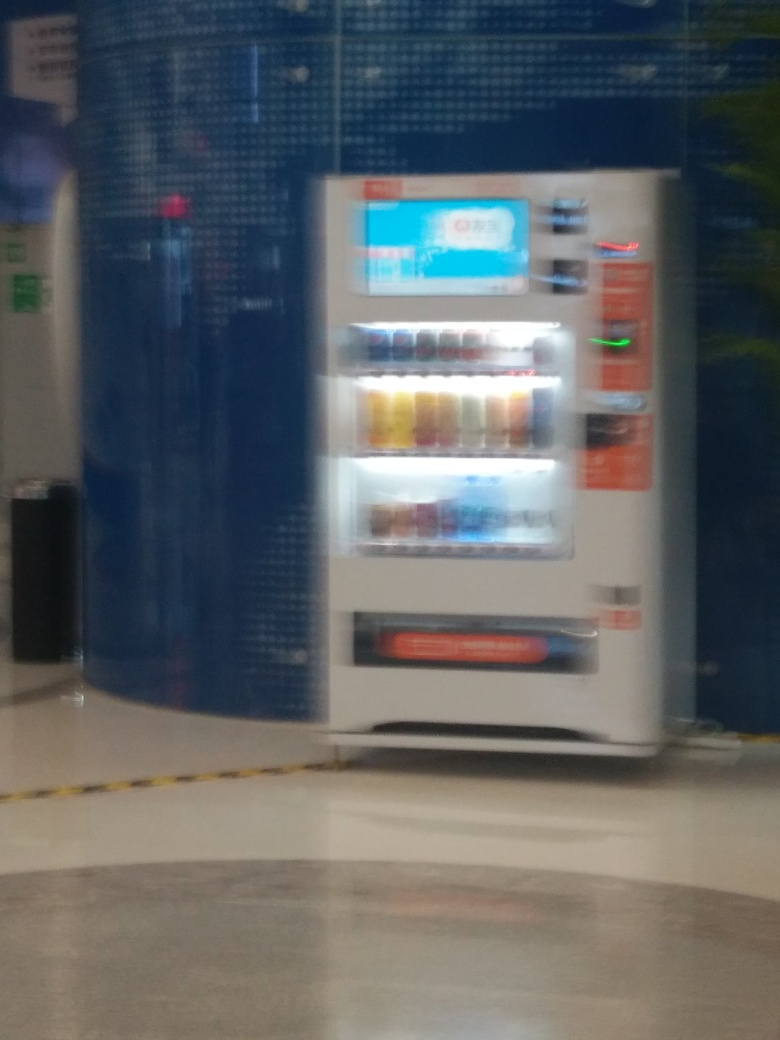What type of machine is depicted in the image? The image appears to show a vending machine, typically used for dispensing beverages and snacks upon payment. Is the machine indoor or outdoor, and how can you tell? The vending machine looks to be placed indoors, as indicated by the tiled flooring and the structured wall behind, which suggest an indoor setting, possibly a hallway or a room designated for vending services. 